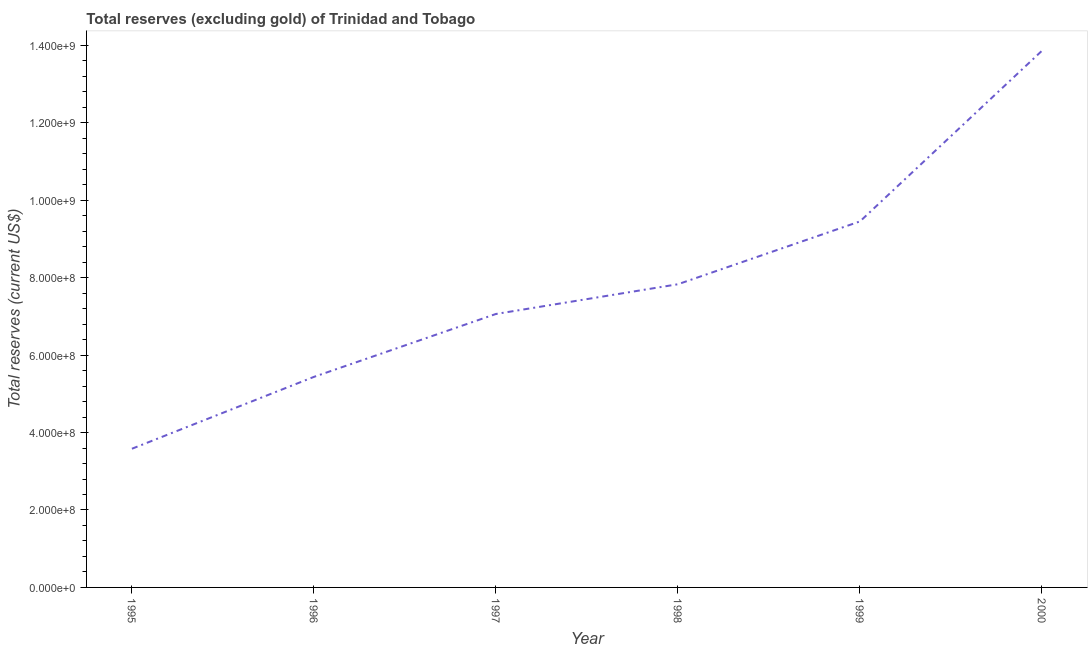What is the total reserves (excluding gold) in 1998?
Offer a terse response. 7.83e+08. Across all years, what is the maximum total reserves (excluding gold)?
Keep it short and to the point. 1.39e+09. Across all years, what is the minimum total reserves (excluding gold)?
Ensure brevity in your answer.  3.58e+08. What is the sum of the total reserves (excluding gold)?
Provide a succinct answer. 4.72e+09. What is the difference between the total reserves (excluding gold) in 1998 and 1999?
Make the answer very short. -1.62e+08. What is the average total reserves (excluding gold) per year?
Offer a terse response. 7.87e+08. What is the median total reserves (excluding gold)?
Your answer should be very brief. 7.45e+08. In how many years, is the total reserves (excluding gold) greater than 240000000 US$?
Keep it short and to the point. 6. Do a majority of the years between 1999 and 2000 (inclusive) have total reserves (excluding gold) greater than 800000000 US$?
Ensure brevity in your answer.  Yes. What is the ratio of the total reserves (excluding gold) in 1995 to that in 1998?
Offer a very short reply. 0.46. Is the total reserves (excluding gold) in 1995 less than that in 1999?
Provide a succinct answer. Yes. Is the difference between the total reserves (excluding gold) in 1997 and 1998 greater than the difference between any two years?
Provide a short and direct response. No. What is the difference between the highest and the second highest total reserves (excluding gold)?
Ensure brevity in your answer.  4.41e+08. Is the sum of the total reserves (excluding gold) in 1996 and 2000 greater than the maximum total reserves (excluding gold) across all years?
Offer a very short reply. Yes. What is the difference between the highest and the lowest total reserves (excluding gold)?
Offer a very short reply. 1.03e+09. In how many years, is the total reserves (excluding gold) greater than the average total reserves (excluding gold) taken over all years?
Your answer should be very brief. 2. How many lines are there?
Offer a terse response. 1. How many years are there in the graph?
Your answer should be compact. 6. What is the difference between two consecutive major ticks on the Y-axis?
Your response must be concise. 2.00e+08. Are the values on the major ticks of Y-axis written in scientific E-notation?
Offer a terse response. Yes. What is the title of the graph?
Offer a very short reply. Total reserves (excluding gold) of Trinidad and Tobago. What is the label or title of the X-axis?
Give a very brief answer. Year. What is the label or title of the Y-axis?
Keep it short and to the point. Total reserves (current US$). What is the Total reserves (current US$) of 1995?
Your answer should be compact. 3.58e+08. What is the Total reserves (current US$) in 1996?
Keep it short and to the point. 5.44e+08. What is the Total reserves (current US$) of 1997?
Give a very brief answer. 7.06e+08. What is the Total reserves (current US$) in 1998?
Offer a very short reply. 7.83e+08. What is the Total reserves (current US$) of 1999?
Keep it short and to the point. 9.45e+08. What is the Total reserves (current US$) in 2000?
Your response must be concise. 1.39e+09. What is the difference between the Total reserves (current US$) in 1995 and 1996?
Give a very brief answer. -1.86e+08. What is the difference between the Total reserves (current US$) in 1995 and 1997?
Your answer should be very brief. -3.48e+08. What is the difference between the Total reserves (current US$) in 1995 and 1998?
Offer a very short reply. -4.25e+08. What is the difference between the Total reserves (current US$) in 1995 and 1999?
Offer a very short reply. -5.87e+08. What is the difference between the Total reserves (current US$) in 1995 and 2000?
Offer a very short reply. -1.03e+09. What is the difference between the Total reserves (current US$) in 1996 and 1997?
Give a very brief answer. -1.62e+08. What is the difference between the Total reserves (current US$) in 1996 and 1998?
Keep it short and to the point. -2.39e+08. What is the difference between the Total reserves (current US$) in 1996 and 1999?
Give a very brief answer. -4.02e+08. What is the difference between the Total reserves (current US$) in 1996 and 2000?
Offer a very short reply. -8.42e+08. What is the difference between the Total reserves (current US$) in 1997 and 1998?
Give a very brief answer. -7.68e+07. What is the difference between the Total reserves (current US$) in 1997 and 1999?
Offer a terse response. -2.39e+08. What is the difference between the Total reserves (current US$) in 1997 and 2000?
Your answer should be compact. -6.80e+08. What is the difference between the Total reserves (current US$) in 1998 and 1999?
Provide a succinct answer. -1.62e+08. What is the difference between the Total reserves (current US$) in 1998 and 2000?
Your answer should be compact. -6.03e+08. What is the difference between the Total reserves (current US$) in 1999 and 2000?
Your answer should be very brief. -4.41e+08. What is the ratio of the Total reserves (current US$) in 1995 to that in 1996?
Provide a succinct answer. 0.66. What is the ratio of the Total reserves (current US$) in 1995 to that in 1997?
Keep it short and to the point. 0.51. What is the ratio of the Total reserves (current US$) in 1995 to that in 1998?
Make the answer very short. 0.46. What is the ratio of the Total reserves (current US$) in 1995 to that in 1999?
Provide a short and direct response. 0.38. What is the ratio of the Total reserves (current US$) in 1995 to that in 2000?
Your response must be concise. 0.26. What is the ratio of the Total reserves (current US$) in 1996 to that in 1997?
Offer a very short reply. 0.77. What is the ratio of the Total reserves (current US$) in 1996 to that in 1998?
Keep it short and to the point. 0.69. What is the ratio of the Total reserves (current US$) in 1996 to that in 1999?
Ensure brevity in your answer.  0.57. What is the ratio of the Total reserves (current US$) in 1996 to that in 2000?
Provide a succinct answer. 0.39. What is the ratio of the Total reserves (current US$) in 1997 to that in 1998?
Ensure brevity in your answer.  0.9. What is the ratio of the Total reserves (current US$) in 1997 to that in 1999?
Provide a succinct answer. 0.75. What is the ratio of the Total reserves (current US$) in 1997 to that in 2000?
Provide a short and direct response. 0.51. What is the ratio of the Total reserves (current US$) in 1998 to that in 1999?
Your answer should be very brief. 0.83. What is the ratio of the Total reserves (current US$) in 1998 to that in 2000?
Offer a terse response. 0.56. What is the ratio of the Total reserves (current US$) in 1999 to that in 2000?
Offer a very short reply. 0.68. 